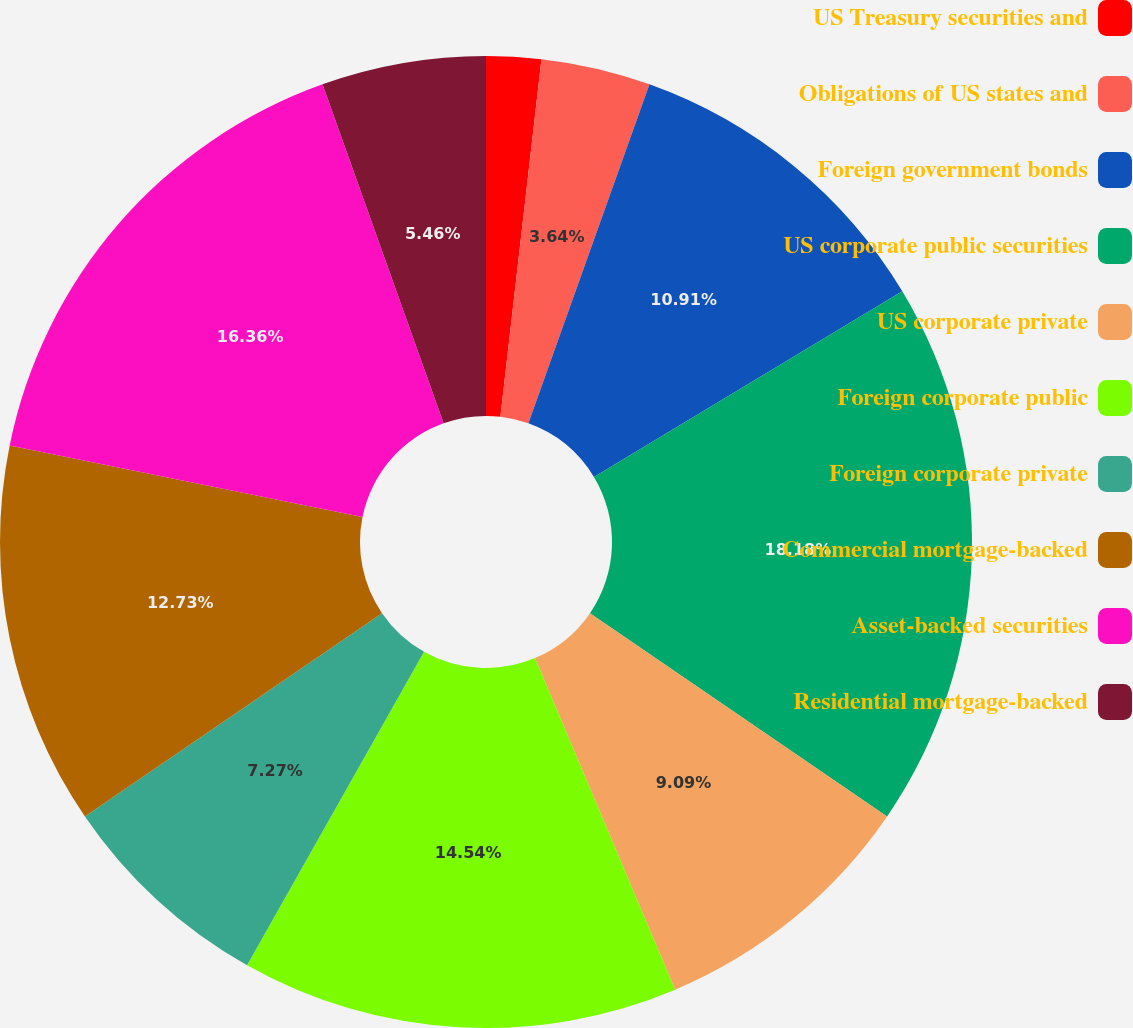Convert chart to OTSL. <chart><loc_0><loc_0><loc_500><loc_500><pie_chart><fcel>US Treasury securities and<fcel>Obligations of US states and<fcel>Foreign government bonds<fcel>US corporate public securities<fcel>US corporate private<fcel>Foreign corporate public<fcel>Foreign corporate private<fcel>Commercial mortgage-backed<fcel>Asset-backed securities<fcel>Residential mortgage-backed<nl><fcel>1.82%<fcel>3.64%<fcel>10.91%<fcel>18.18%<fcel>9.09%<fcel>14.54%<fcel>7.27%<fcel>12.73%<fcel>16.36%<fcel>5.46%<nl></chart> 